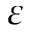<formula> <loc_0><loc_0><loc_500><loc_500>\varepsilon</formula> 